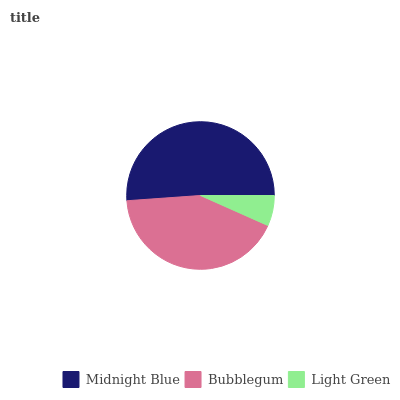Is Light Green the minimum?
Answer yes or no. Yes. Is Midnight Blue the maximum?
Answer yes or no. Yes. Is Bubblegum the minimum?
Answer yes or no. No. Is Bubblegum the maximum?
Answer yes or no. No. Is Midnight Blue greater than Bubblegum?
Answer yes or no. Yes. Is Bubblegum less than Midnight Blue?
Answer yes or no. Yes. Is Bubblegum greater than Midnight Blue?
Answer yes or no. No. Is Midnight Blue less than Bubblegum?
Answer yes or no. No. Is Bubblegum the high median?
Answer yes or no. Yes. Is Bubblegum the low median?
Answer yes or no. Yes. Is Midnight Blue the high median?
Answer yes or no. No. Is Light Green the low median?
Answer yes or no. No. 